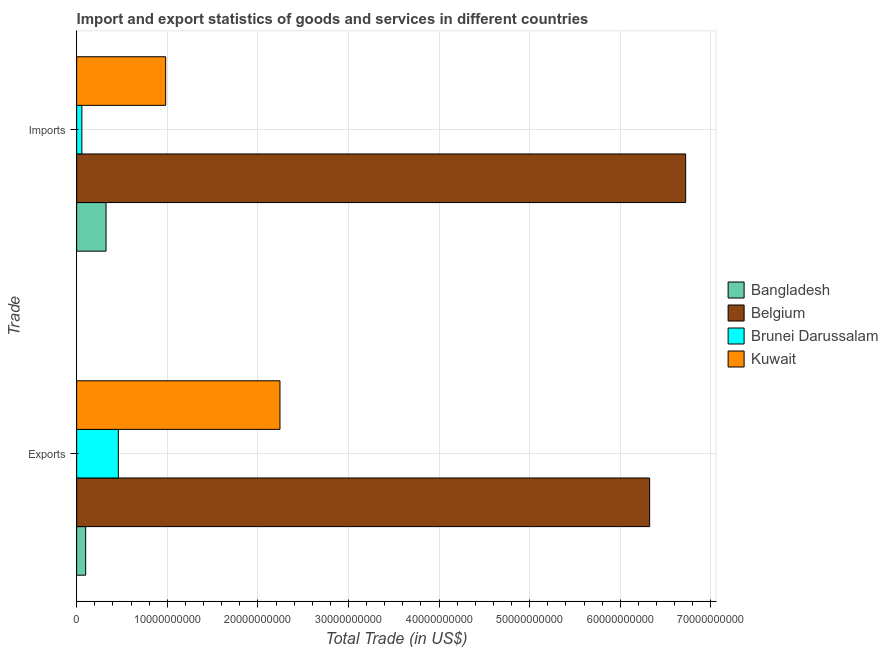Are the number of bars on each tick of the Y-axis equal?
Provide a succinct answer. Yes. How many bars are there on the 2nd tick from the bottom?
Your response must be concise. 4. What is the label of the 2nd group of bars from the top?
Give a very brief answer. Exports. What is the export of goods and services in Belgium?
Provide a succinct answer. 6.32e+1. Across all countries, what is the maximum imports of goods and services?
Ensure brevity in your answer.  6.72e+1. Across all countries, what is the minimum imports of goods and services?
Ensure brevity in your answer.  5.75e+08. In which country was the export of goods and services maximum?
Provide a succinct answer. Belgium. In which country was the export of goods and services minimum?
Offer a very short reply. Bangladesh. What is the total imports of goods and services in the graph?
Make the answer very short. 8.09e+1. What is the difference between the imports of goods and services in Belgium and that in Bangladesh?
Give a very brief answer. 6.40e+1. What is the difference between the export of goods and services in Kuwait and the imports of goods and services in Bangladesh?
Your answer should be very brief. 1.92e+1. What is the average imports of goods and services per country?
Provide a short and direct response. 2.02e+1. What is the difference between the export of goods and services and imports of goods and services in Brunei Darussalam?
Your answer should be compact. 4.03e+09. In how many countries, is the export of goods and services greater than 32000000000 US$?
Your answer should be very brief. 1. What is the ratio of the export of goods and services in Brunei Darussalam to that in Kuwait?
Keep it short and to the point. 0.21. What does the 4th bar from the top in Exports represents?
Ensure brevity in your answer.  Bangladesh. Are all the bars in the graph horizontal?
Your answer should be very brief. Yes. What is the difference between two consecutive major ticks on the X-axis?
Ensure brevity in your answer.  1.00e+1. Does the graph contain any zero values?
Make the answer very short. No. Does the graph contain grids?
Give a very brief answer. Yes. How are the legend labels stacked?
Give a very brief answer. Vertical. What is the title of the graph?
Offer a terse response. Import and export statistics of goods and services in different countries. Does "Cameroon" appear as one of the legend labels in the graph?
Give a very brief answer. No. What is the label or title of the X-axis?
Your response must be concise. Total Trade (in US$). What is the label or title of the Y-axis?
Give a very brief answer. Trade. What is the Total Trade (in US$) of Bangladesh in Exports?
Provide a succinct answer. 9.97e+08. What is the Total Trade (in US$) in Belgium in Exports?
Give a very brief answer. 6.32e+1. What is the Total Trade (in US$) in Brunei Darussalam in Exports?
Make the answer very short. 4.60e+09. What is the Total Trade (in US$) in Kuwait in Exports?
Your answer should be compact. 2.24e+1. What is the Total Trade (in US$) in Bangladesh in Imports?
Provide a short and direct response. 3.24e+09. What is the Total Trade (in US$) in Belgium in Imports?
Your answer should be very brief. 6.72e+1. What is the Total Trade (in US$) of Brunei Darussalam in Imports?
Keep it short and to the point. 5.75e+08. What is the Total Trade (in US$) of Kuwait in Imports?
Ensure brevity in your answer.  9.82e+09. Across all Trade, what is the maximum Total Trade (in US$) of Bangladesh?
Give a very brief answer. 3.24e+09. Across all Trade, what is the maximum Total Trade (in US$) in Belgium?
Make the answer very short. 6.72e+1. Across all Trade, what is the maximum Total Trade (in US$) of Brunei Darussalam?
Offer a terse response. 4.60e+09. Across all Trade, what is the maximum Total Trade (in US$) of Kuwait?
Your answer should be compact. 2.24e+1. Across all Trade, what is the minimum Total Trade (in US$) in Bangladesh?
Your answer should be compact. 9.97e+08. Across all Trade, what is the minimum Total Trade (in US$) of Belgium?
Your answer should be very brief. 6.32e+1. Across all Trade, what is the minimum Total Trade (in US$) in Brunei Darussalam?
Provide a succinct answer. 5.75e+08. Across all Trade, what is the minimum Total Trade (in US$) in Kuwait?
Offer a terse response. 9.82e+09. What is the total Total Trade (in US$) in Bangladesh in the graph?
Make the answer very short. 4.24e+09. What is the total Total Trade (in US$) of Belgium in the graph?
Provide a short and direct response. 1.30e+11. What is the total Total Trade (in US$) of Brunei Darussalam in the graph?
Your answer should be compact. 5.18e+09. What is the total Total Trade (in US$) in Kuwait in the graph?
Your response must be concise. 3.23e+1. What is the difference between the Total Trade (in US$) of Bangladesh in Exports and that in Imports?
Your response must be concise. -2.25e+09. What is the difference between the Total Trade (in US$) of Belgium in Exports and that in Imports?
Offer a very short reply. -3.97e+09. What is the difference between the Total Trade (in US$) of Brunei Darussalam in Exports and that in Imports?
Provide a short and direct response. 4.03e+09. What is the difference between the Total Trade (in US$) in Kuwait in Exports and that in Imports?
Your answer should be very brief. 1.26e+1. What is the difference between the Total Trade (in US$) of Bangladesh in Exports and the Total Trade (in US$) of Belgium in Imports?
Offer a terse response. -6.62e+1. What is the difference between the Total Trade (in US$) in Bangladesh in Exports and the Total Trade (in US$) in Brunei Darussalam in Imports?
Ensure brevity in your answer.  4.22e+08. What is the difference between the Total Trade (in US$) of Bangladesh in Exports and the Total Trade (in US$) of Kuwait in Imports?
Make the answer very short. -8.83e+09. What is the difference between the Total Trade (in US$) in Belgium in Exports and the Total Trade (in US$) in Brunei Darussalam in Imports?
Ensure brevity in your answer.  6.27e+1. What is the difference between the Total Trade (in US$) of Belgium in Exports and the Total Trade (in US$) of Kuwait in Imports?
Provide a succinct answer. 5.34e+1. What is the difference between the Total Trade (in US$) of Brunei Darussalam in Exports and the Total Trade (in US$) of Kuwait in Imports?
Provide a succinct answer. -5.22e+09. What is the average Total Trade (in US$) of Bangladesh per Trade?
Make the answer very short. 2.12e+09. What is the average Total Trade (in US$) in Belgium per Trade?
Make the answer very short. 6.52e+1. What is the average Total Trade (in US$) of Brunei Darussalam per Trade?
Make the answer very short. 2.59e+09. What is the average Total Trade (in US$) in Kuwait per Trade?
Provide a succinct answer. 1.61e+1. What is the difference between the Total Trade (in US$) in Bangladesh and Total Trade (in US$) in Belgium in Exports?
Offer a terse response. -6.22e+1. What is the difference between the Total Trade (in US$) in Bangladesh and Total Trade (in US$) in Brunei Darussalam in Exports?
Your response must be concise. -3.61e+09. What is the difference between the Total Trade (in US$) of Bangladesh and Total Trade (in US$) of Kuwait in Exports?
Offer a very short reply. -2.14e+1. What is the difference between the Total Trade (in US$) in Belgium and Total Trade (in US$) in Brunei Darussalam in Exports?
Give a very brief answer. 5.86e+1. What is the difference between the Total Trade (in US$) in Belgium and Total Trade (in US$) in Kuwait in Exports?
Provide a short and direct response. 4.08e+1. What is the difference between the Total Trade (in US$) in Brunei Darussalam and Total Trade (in US$) in Kuwait in Exports?
Your response must be concise. -1.78e+1. What is the difference between the Total Trade (in US$) of Bangladesh and Total Trade (in US$) of Belgium in Imports?
Your response must be concise. -6.40e+1. What is the difference between the Total Trade (in US$) of Bangladesh and Total Trade (in US$) of Brunei Darussalam in Imports?
Provide a short and direct response. 2.67e+09. What is the difference between the Total Trade (in US$) in Bangladesh and Total Trade (in US$) in Kuwait in Imports?
Give a very brief answer. -6.58e+09. What is the difference between the Total Trade (in US$) in Belgium and Total Trade (in US$) in Brunei Darussalam in Imports?
Your answer should be very brief. 6.66e+1. What is the difference between the Total Trade (in US$) of Belgium and Total Trade (in US$) of Kuwait in Imports?
Make the answer very short. 5.74e+1. What is the difference between the Total Trade (in US$) of Brunei Darussalam and Total Trade (in US$) of Kuwait in Imports?
Your answer should be compact. -9.25e+09. What is the ratio of the Total Trade (in US$) in Bangladesh in Exports to that in Imports?
Your response must be concise. 0.31. What is the ratio of the Total Trade (in US$) of Belgium in Exports to that in Imports?
Your response must be concise. 0.94. What is the ratio of the Total Trade (in US$) in Brunei Darussalam in Exports to that in Imports?
Provide a succinct answer. 8. What is the ratio of the Total Trade (in US$) of Kuwait in Exports to that in Imports?
Your response must be concise. 2.28. What is the difference between the highest and the second highest Total Trade (in US$) of Bangladesh?
Your answer should be compact. 2.25e+09. What is the difference between the highest and the second highest Total Trade (in US$) of Belgium?
Your answer should be very brief. 3.97e+09. What is the difference between the highest and the second highest Total Trade (in US$) of Brunei Darussalam?
Your response must be concise. 4.03e+09. What is the difference between the highest and the second highest Total Trade (in US$) of Kuwait?
Provide a short and direct response. 1.26e+1. What is the difference between the highest and the lowest Total Trade (in US$) in Bangladesh?
Provide a succinct answer. 2.25e+09. What is the difference between the highest and the lowest Total Trade (in US$) of Belgium?
Offer a terse response. 3.97e+09. What is the difference between the highest and the lowest Total Trade (in US$) of Brunei Darussalam?
Your response must be concise. 4.03e+09. What is the difference between the highest and the lowest Total Trade (in US$) in Kuwait?
Your answer should be very brief. 1.26e+1. 